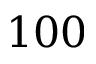Convert formula to latex. <formula><loc_0><loc_0><loc_500><loc_500>1 0 0</formula> 